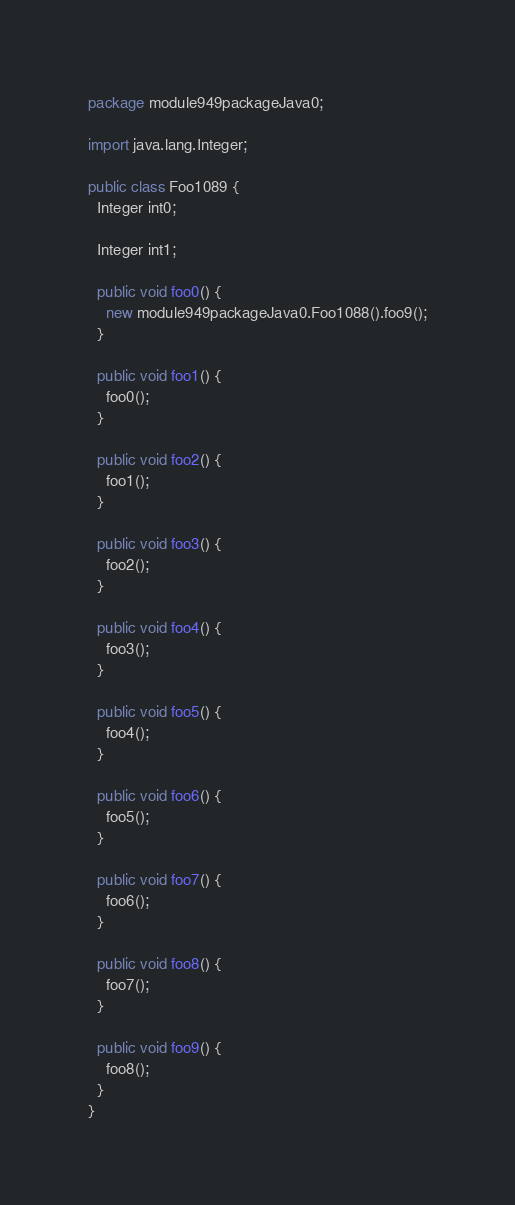Convert code to text. <code><loc_0><loc_0><loc_500><loc_500><_Java_>package module949packageJava0;

import java.lang.Integer;

public class Foo1089 {
  Integer int0;

  Integer int1;

  public void foo0() {
    new module949packageJava0.Foo1088().foo9();
  }

  public void foo1() {
    foo0();
  }

  public void foo2() {
    foo1();
  }

  public void foo3() {
    foo2();
  }

  public void foo4() {
    foo3();
  }

  public void foo5() {
    foo4();
  }

  public void foo6() {
    foo5();
  }

  public void foo7() {
    foo6();
  }

  public void foo8() {
    foo7();
  }

  public void foo9() {
    foo8();
  }
}
</code> 